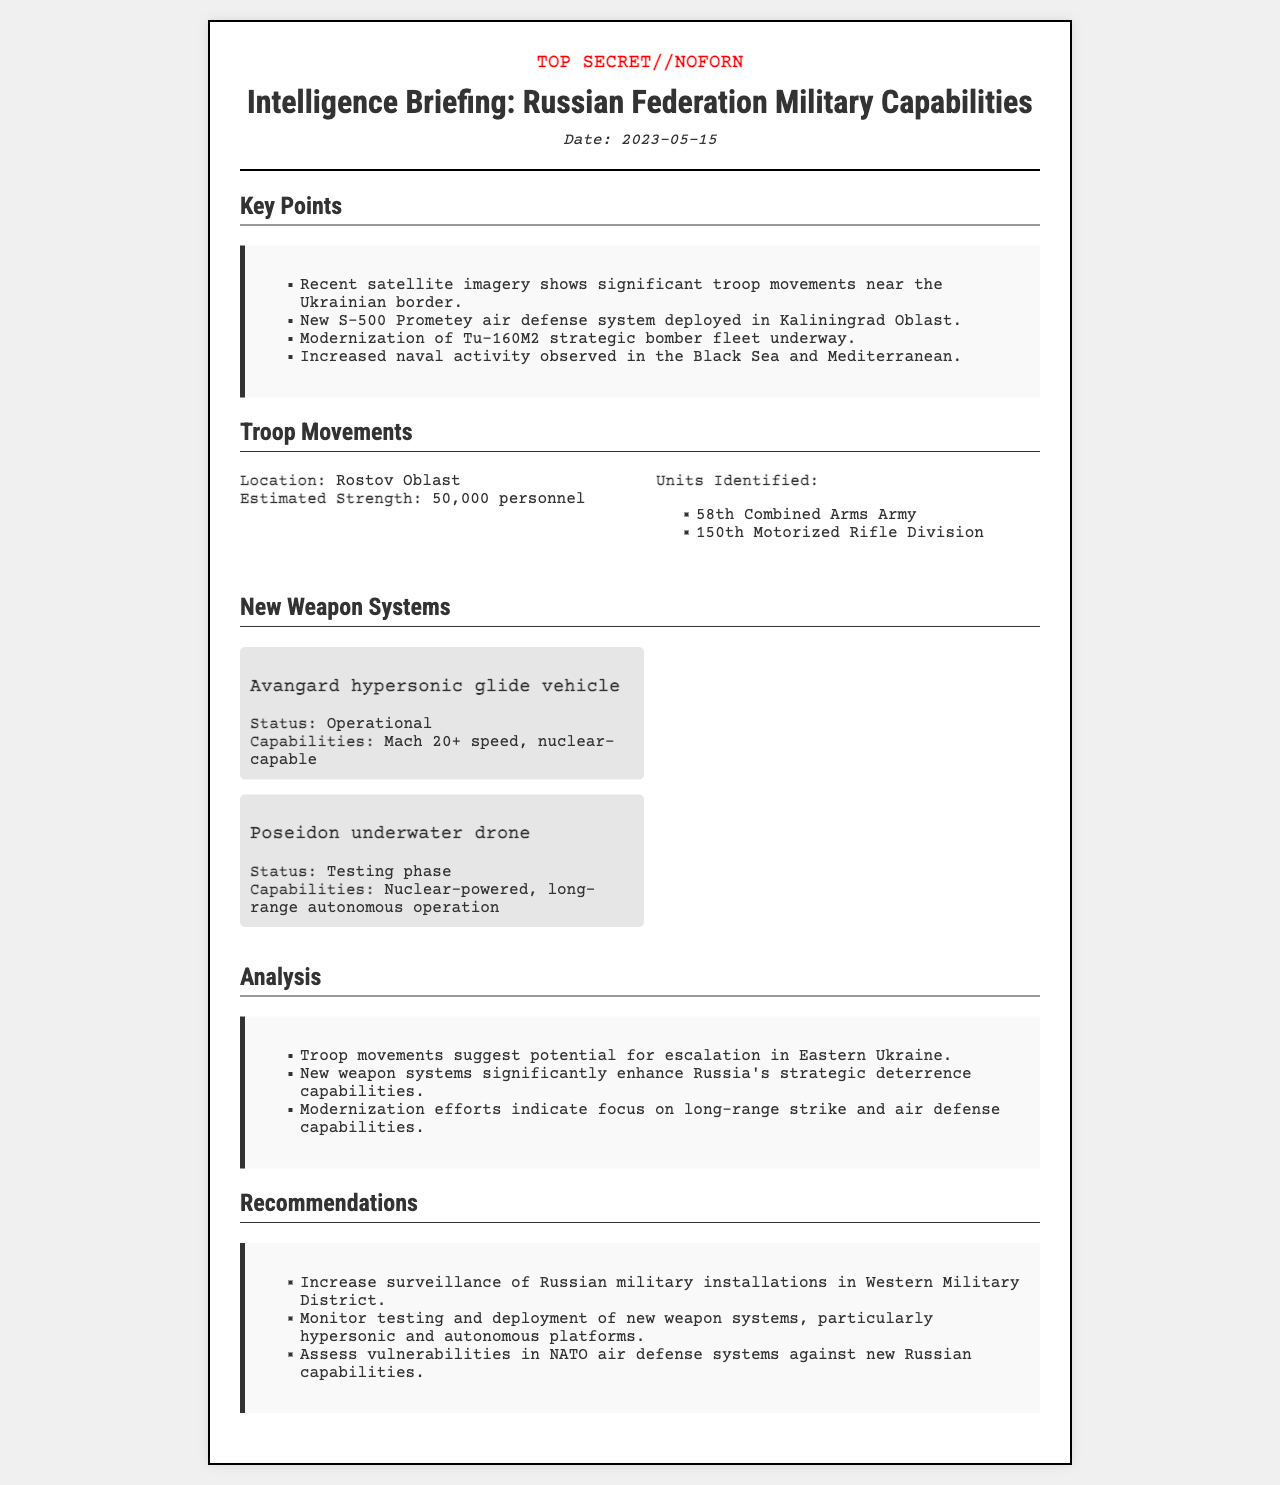What is the date of the intelligence briefing? The date of the intelligence briefing is clearly stated in the document header.
Answer: 2023-05-15 How many personnel are estimated in Rostov Oblast? The estimated strength in Rostov Oblast is provided in the troop movements section.
Answer: 50,000 personnel What new air defense system has been deployed? The document mentions the new air defense system in the key points section.
Answer: S-500 Prometey What is the status of the Avangard hypersonic glide vehicle? The status of the Avangard hypersonic glide vehicle can be found in the new weapon systems section.
Answer: Operational What military units are identified in Rostov Oblast? The units identified are listed under troop movements in the document.
Answer: 58th Combined Arms Army, 150th Motorized Rifle Division What does the analysis suggest about troop movements? The analysis mentions implications of troop movements and requires understanding of provided points.
Answer: Potential for escalation in Eastern Ukraine What are the recommendations regarding monitoring? Recommendations are made regarding military installations in the context of the document's content.
Answer: Increase surveillance of Russian military installations in Western Military District What is the primary focus of Russia's modernization efforts? The analysis section discusses the focus of Russia's modernization efforts based on the new systems mentioned.
Answer: Long-range strike and air defense capabilities 